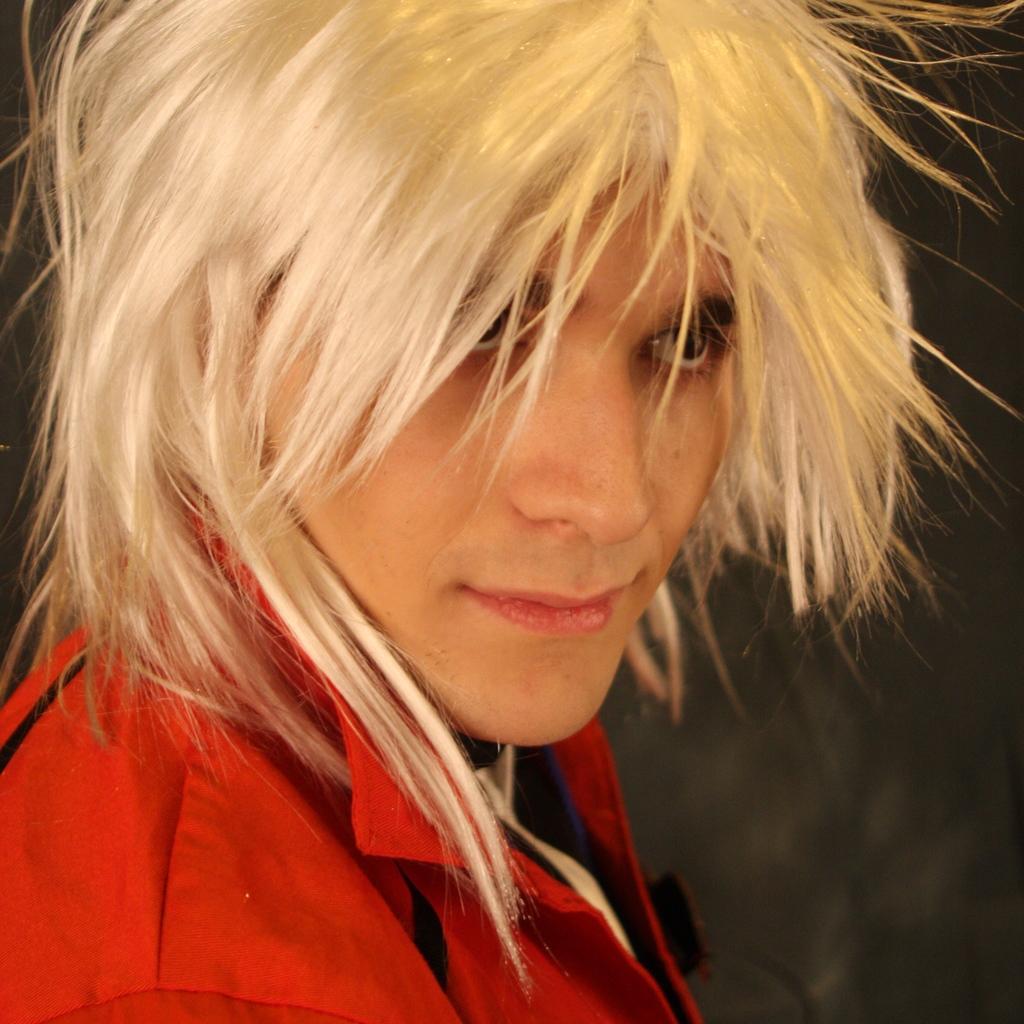Can you describe this image briefly? In this image there is a person standing on the floor. 